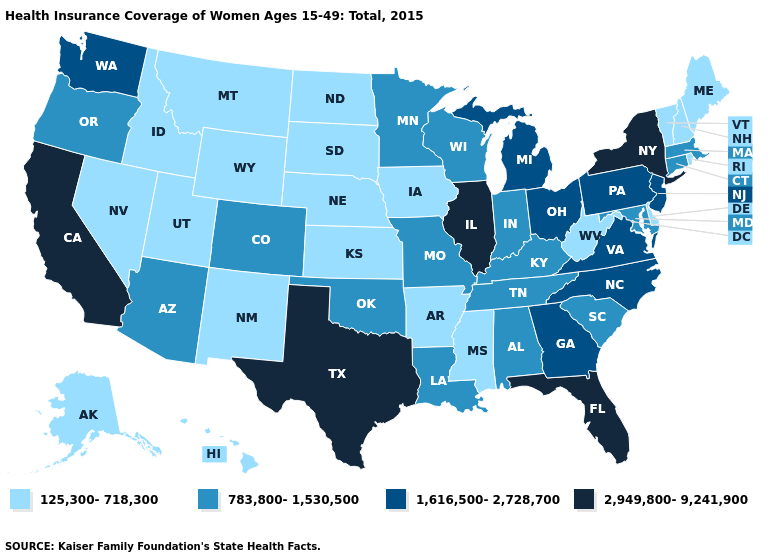Name the states that have a value in the range 125,300-718,300?
Concise answer only. Alaska, Arkansas, Delaware, Hawaii, Idaho, Iowa, Kansas, Maine, Mississippi, Montana, Nebraska, Nevada, New Hampshire, New Mexico, North Dakota, Rhode Island, South Dakota, Utah, Vermont, West Virginia, Wyoming. How many symbols are there in the legend?
Answer briefly. 4. What is the value of Kansas?
Keep it brief. 125,300-718,300. Name the states that have a value in the range 125,300-718,300?
Keep it brief. Alaska, Arkansas, Delaware, Hawaii, Idaho, Iowa, Kansas, Maine, Mississippi, Montana, Nebraska, Nevada, New Hampshire, New Mexico, North Dakota, Rhode Island, South Dakota, Utah, Vermont, West Virginia, Wyoming. Name the states that have a value in the range 1,616,500-2,728,700?
Keep it brief. Georgia, Michigan, New Jersey, North Carolina, Ohio, Pennsylvania, Virginia, Washington. What is the highest value in the USA?
Write a very short answer. 2,949,800-9,241,900. What is the value of Florida?
Be succinct. 2,949,800-9,241,900. Does Maryland have a lower value than Kentucky?
Answer briefly. No. Does South Dakota have the highest value in the USA?
Concise answer only. No. Is the legend a continuous bar?
Concise answer only. No. What is the lowest value in states that border Missouri?
Be succinct. 125,300-718,300. Among the states that border New Mexico , which have the lowest value?
Quick response, please. Utah. Name the states that have a value in the range 783,800-1,530,500?
Keep it brief. Alabama, Arizona, Colorado, Connecticut, Indiana, Kentucky, Louisiana, Maryland, Massachusetts, Minnesota, Missouri, Oklahoma, Oregon, South Carolina, Tennessee, Wisconsin. What is the value of Connecticut?
Quick response, please. 783,800-1,530,500. 